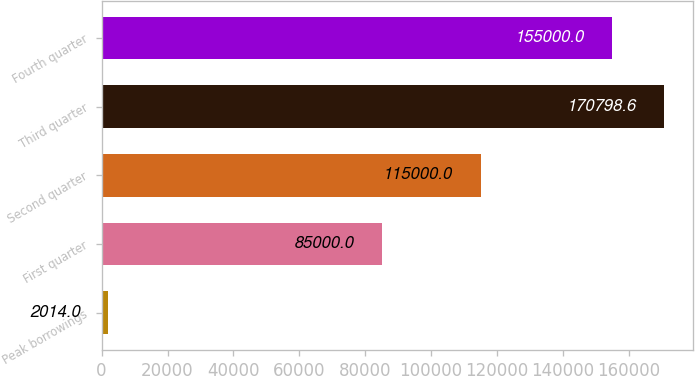<chart> <loc_0><loc_0><loc_500><loc_500><bar_chart><fcel>Peak borrowings<fcel>First quarter<fcel>Second quarter<fcel>Third quarter<fcel>Fourth quarter<nl><fcel>2014<fcel>85000<fcel>115000<fcel>170799<fcel>155000<nl></chart> 